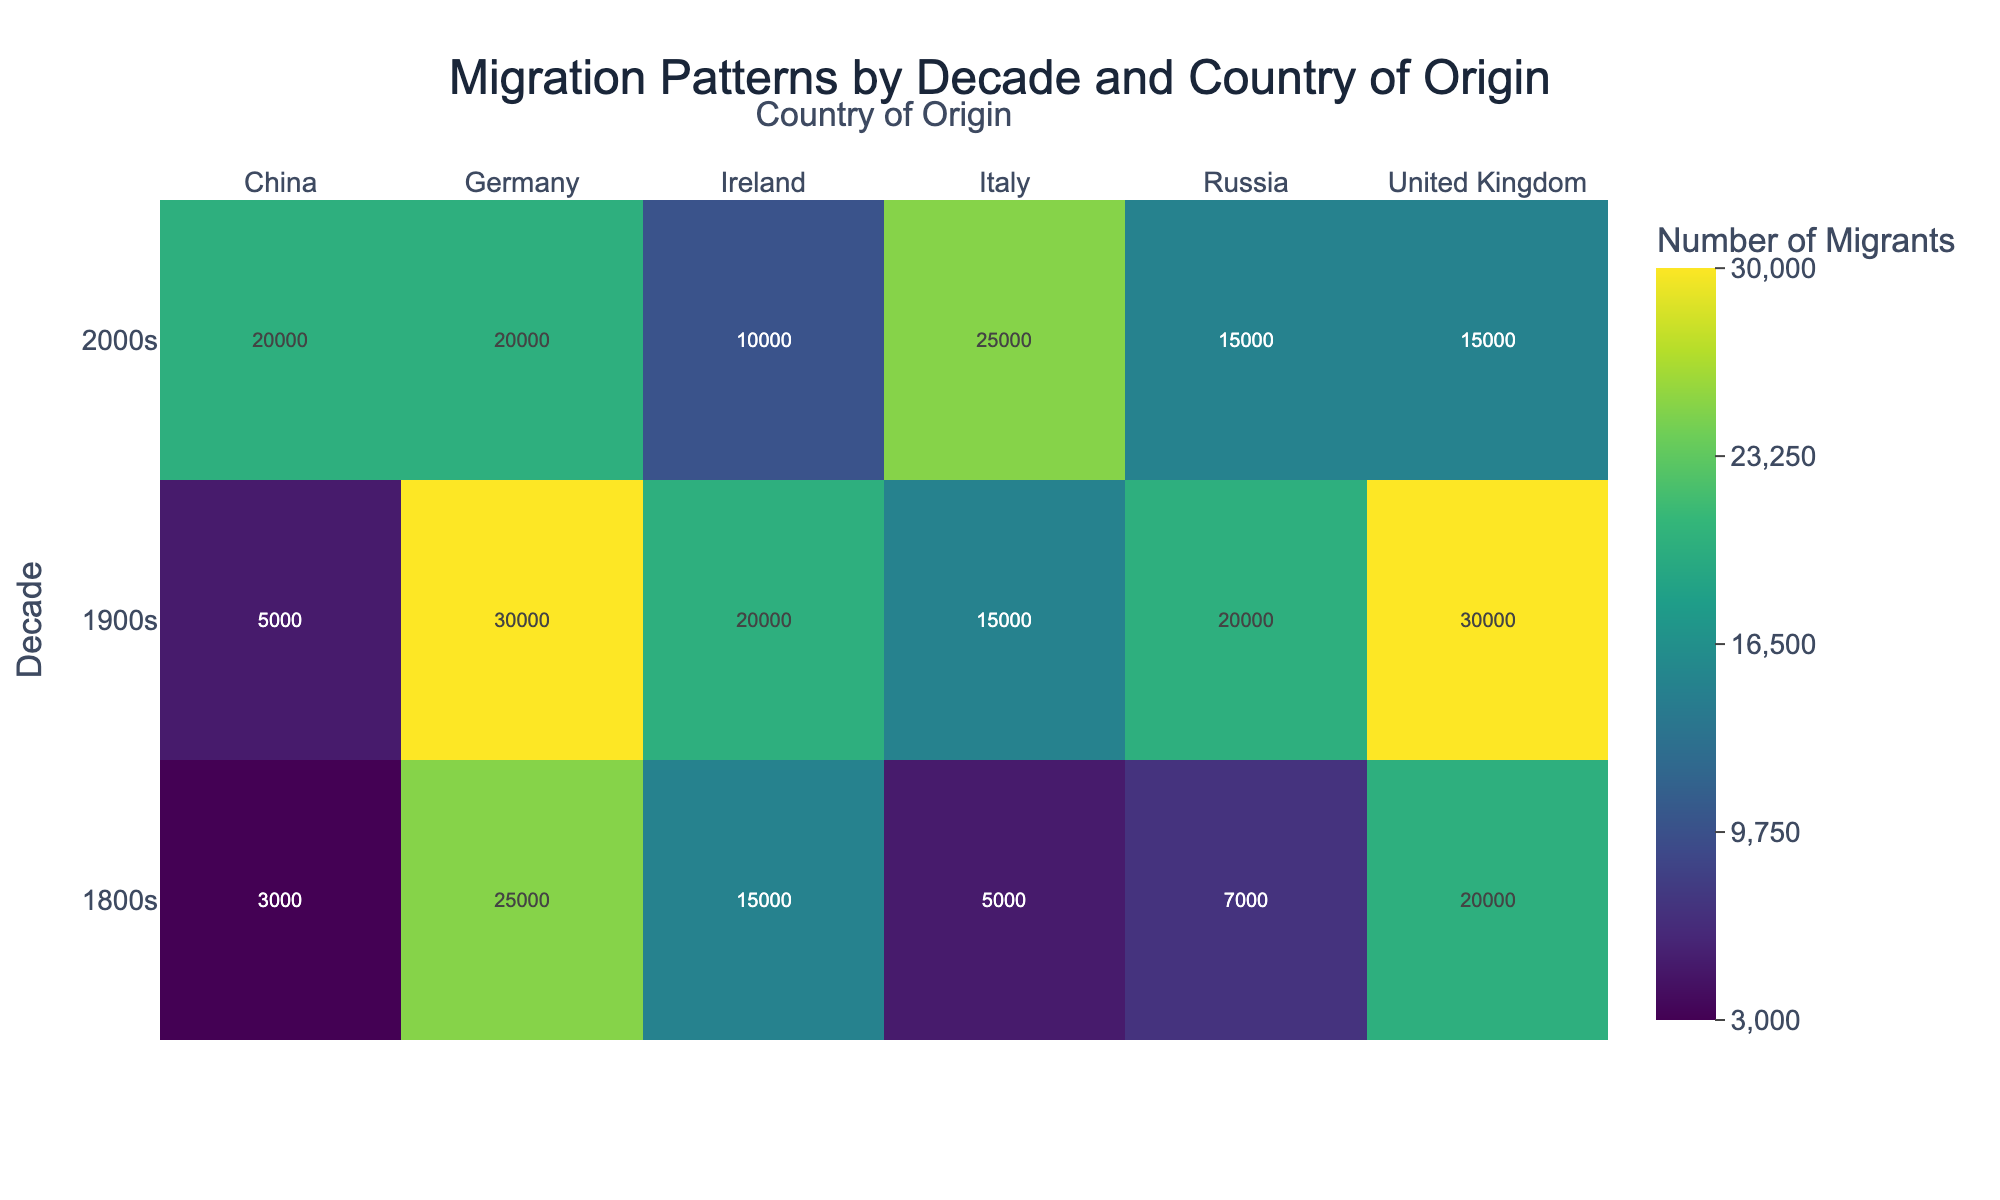What is the title of the heatmap? The title is displayed at the top center of the heatmap. It is clear and formatted in a larger font size.
Answer: Migration Patterns by Decade and Country of Origin Which decade has the highest number of migrants overall? To find this, sum the number of migrants for each decade and compare. Adding the numbers for the 1900s gives the highest total compared to the 1800s and 2000s.
Answer: 1900s Which country of origin has the least number of migrants in the 1800s? Look at the row corresponding to the 1800s and compare the values of each country. The country with the smallest number is China.
Answer: China How does the migration from Italy change over the decades? Trace the values corresponding to Italy across the three decades. Italy had 5,000 migrants in the 1800s, 15,000 in the 1900s, and 25,000 in the 2000s, showing an increasing trend.
Answer: Increases Which country of origin has the same number of migrants in both the 1800s and 1900s? Check which country has the same number in both the corresponding rows. Germany shows 25,000 migrants in the 1800s and the same 25,000 in the 1900s.
Answer: Germany Between China and Ireland, which country saw a greater reduction in the number of migrants from the 1900s to the 2000s? Calculate the difference in migrants from the 1900s to the 2000s for both countries. For China, it is 5,000 - 20,000 = -15,000, and for Ireland, it is 20,000 - 10,000 = 10,000, indicating China had a greater reduction.
Answer: China What is the color scheme used in the heatmap? The heatmap uses the 'Viridis' color scale, which provides a gradient of colors to indicate varying intensities. Colors range from dark purple for lower values to bright yellow for higher values.
Answer: Viridis Which country of origin contributed the most migrants in the 2000s? Examine the row for the 2000s and identify the country with the highest number. Italy has the highest number with 25,000 migrants.
Answer: Italy What is the total number of migrants from Russia across all three decades? Add up the number of migrants for Russia from each decade: 7,000 + 20,000 + 15,000 = 42,000.
Answer: 42,000 